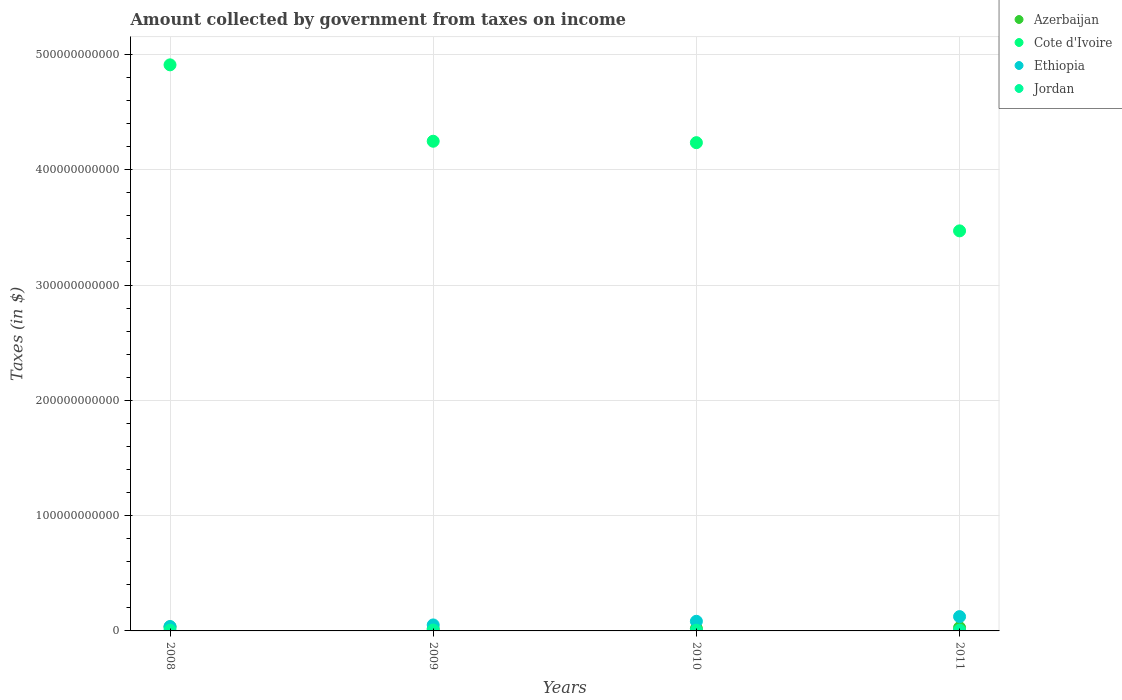Is the number of dotlines equal to the number of legend labels?
Provide a short and direct response. Yes. What is the amount collected by government from taxes on income in Azerbaijan in 2008?
Provide a short and direct response. 3.50e+09. Across all years, what is the maximum amount collected by government from taxes on income in Ethiopia?
Your answer should be very brief. 1.24e+1. Across all years, what is the minimum amount collected by government from taxes on income in Jordan?
Make the answer very short. 6.03e+08. What is the total amount collected by government from taxes on income in Jordan in the graph?
Your response must be concise. 2.66e+09. What is the difference between the amount collected by government from taxes on income in Ethiopia in 2008 and that in 2009?
Offer a terse response. -1.39e+09. What is the difference between the amount collected by government from taxes on income in Ethiopia in 2008 and the amount collected by government from taxes on income in Jordan in 2009?
Your response must be concise. 3.03e+09. What is the average amount collected by government from taxes on income in Ethiopia per year?
Provide a short and direct response. 7.44e+09. In the year 2009, what is the difference between the amount collected by government from taxes on income in Cote d'Ivoire and amount collected by government from taxes on income in Jordan?
Offer a very short reply. 4.24e+11. What is the ratio of the amount collected by government from taxes on income in Ethiopia in 2008 to that in 2011?
Offer a very short reply. 0.31. Is the amount collected by government from taxes on income in Ethiopia in 2008 less than that in 2009?
Provide a short and direct response. Yes. Is the difference between the amount collected by government from taxes on income in Cote d'Ivoire in 2008 and 2009 greater than the difference between the amount collected by government from taxes on income in Jordan in 2008 and 2009?
Keep it short and to the point. Yes. What is the difference between the highest and the second highest amount collected by government from taxes on income in Ethiopia?
Give a very brief answer. 4.06e+09. What is the difference between the highest and the lowest amount collected by government from taxes on income in Ethiopia?
Your response must be concise. 8.62e+09. Is it the case that in every year, the sum of the amount collected by government from taxes on income in Azerbaijan and amount collected by government from taxes on income in Jordan  is greater than the amount collected by government from taxes on income in Cote d'Ivoire?
Your answer should be compact. No. Is the amount collected by government from taxes on income in Ethiopia strictly greater than the amount collected by government from taxes on income in Cote d'Ivoire over the years?
Give a very brief answer. No. Is the amount collected by government from taxes on income in Cote d'Ivoire strictly less than the amount collected by government from taxes on income in Azerbaijan over the years?
Offer a very short reply. No. How many dotlines are there?
Ensure brevity in your answer.  4. How many years are there in the graph?
Your answer should be compact. 4. What is the difference between two consecutive major ticks on the Y-axis?
Offer a very short reply. 1.00e+11. How many legend labels are there?
Offer a terse response. 4. What is the title of the graph?
Your answer should be compact. Amount collected by government from taxes on income. Does "Cyprus" appear as one of the legend labels in the graph?
Offer a very short reply. No. What is the label or title of the Y-axis?
Ensure brevity in your answer.  Taxes (in $). What is the Taxes (in $) in Azerbaijan in 2008?
Keep it short and to the point. 3.50e+09. What is the Taxes (in $) in Cote d'Ivoire in 2008?
Your answer should be compact. 4.91e+11. What is the Taxes (in $) in Ethiopia in 2008?
Make the answer very short. 3.80e+09. What is the Taxes (in $) of Jordan in 2008?
Your answer should be compact. 6.03e+08. What is the Taxes (in $) of Azerbaijan in 2009?
Keep it short and to the point. 1.92e+09. What is the Taxes (in $) in Cote d'Ivoire in 2009?
Keep it short and to the point. 4.25e+11. What is the Taxes (in $) of Ethiopia in 2009?
Ensure brevity in your answer.  5.19e+09. What is the Taxes (in $) in Jordan in 2009?
Make the answer very short. 7.65e+08. What is the Taxes (in $) in Azerbaijan in 2010?
Make the answer very short. 2.03e+09. What is the Taxes (in $) of Cote d'Ivoire in 2010?
Your answer should be compact. 4.24e+11. What is the Taxes (in $) in Ethiopia in 2010?
Offer a very short reply. 8.35e+09. What is the Taxes (in $) in Jordan in 2010?
Your response must be concise. 6.25e+08. What is the Taxes (in $) of Azerbaijan in 2011?
Give a very brief answer. 2.86e+09. What is the Taxes (in $) of Cote d'Ivoire in 2011?
Keep it short and to the point. 3.47e+11. What is the Taxes (in $) of Ethiopia in 2011?
Keep it short and to the point. 1.24e+1. What is the Taxes (in $) in Jordan in 2011?
Keep it short and to the point. 6.68e+08. Across all years, what is the maximum Taxes (in $) in Azerbaijan?
Your response must be concise. 3.50e+09. Across all years, what is the maximum Taxes (in $) in Cote d'Ivoire?
Your answer should be compact. 4.91e+11. Across all years, what is the maximum Taxes (in $) of Ethiopia?
Provide a short and direct response. 1.24e+1. Across all years, what is the maximum Taxes (in $) in Jordan?
Your response must be concise. 7.65e+08. Across all years, what is the minimum Taxes (in $) in Azerbaijan?
Offer a very short reply. 1.92e+09. Across all years, what is the minimum Taxes (in $) in Cote d'Ivoire?
Your answer should be very brief. 3.47e+11. Across all years, what is the minimum Taxes (in $) in Ethiopia?
Your answer should be very brief. 3.80e+09. Across all years, what is the minimum Taxes (in $) of Jordan?
Keep it short and to the point. 6.03e+08. What is the total Taxes (in $) in Azerbaijan in the graph?
Provide a short and direct response. 1.03e+1. What is the total Taxes (in $) in Cote d'Ivoire in the graph?
Your answer should be compact. 1.69e+12. What is the total Taxes (in $) of Ethiopia in the graph?
Ensure brevity in your answer.  2.98e+1. What is the total Taxes (in $) of Jordan in the graph?
Your response must be concise. 2.66e+09. What is the difference between the Taxes (in $) of Azerbaijan in 2008 and that in 2009?
Provide a succinct answer. 1.58e+09. What is the difference between the Taxes (in $) of Cote d'Ivoire in 2008 and that in 2009?
Ensure brevity in your answer.  6.63e+1. What is the difference between the Taxes (in $) of Ethiopia in 2008 and that in 2009?
Your answer should be very brief. -1.39e+09. What is the difference between the Taxes (in $) of Jordan in 2008 and that in 2009?
Ensure brevity in your answer.  -1.61e+08. What is the difference between the Taxes (in $) in Azerbaijan in 2008 and that in 2010?
Make the answer very short. 1.47e+09. What is the difference between the Taxes (in $) in Cote d'Ivoire in 2008 and that in 2010?
Make the answer very short. 6.75e+1. What is the difference between the Taxes (in $) in Ethiopia in 2008 and that in 2010?
Keep it short and to the point. -4.56e+09. What is the difference between the Taxes (in $) of Jordan in 2008 and that in 2010?
Provide a short and direct response. -2.12e+07. What is the difference between the Taxes (in $) of Azerbaijan in 2008 and that in 2011?
Provide a short and direct response. 6.37e+08. What is the difference between the Taxes (in $) in Cote d'Ivoire in 2008 and that in 2011?
Your answer should be compact. 1.44e+11. What is the difference between the Taxes (in $) of Ethiopia in 2008 and that in 2011?
Your response must be concise. -8.62e+09. What is the difference between the Taxes (in $) of Jordan in 2008 and that in 2011?
Make the answer very short. -6.41e+07. What is the difference between the Taxes (in $) of Azerbaijan in 2009 and that in 2010?
Make the answer very short. -1.06e+08. What is the difference between the Taxes (in $) of Cote d'Ivoire in 2009 and that in 2010?
Your answer should be very brief. 1.24e+09. What is the difference between the Taxes (in $) in Ethiopia in 2009 and that in 2010?
Make the answer very short. -3.16e+09. What is the difference between the Taxes (in $) in Jordan in 2009 and that in 2010?
Provide a short and direct response. 1.40e+08. What is the difference between the Taxes (in $) in Azerbaijan in 2009 and that in 2011?
Offer a terse response. -9.41e+08. What is the difference between the Taxes (in $) of Cote d'Ivoire in 2009 and that in 2011?
Give a very brief answer. 7.77e+1. What is the difference between the Taxes (in $) of Ethiopia in 2009 and that in 2011?
Provide a short and direct response. -7.22e+09. What is the difference between the Taxes (in $) of Jordan in 2009 and that in 2011?
Your answer should be very brief. 9.72e+07. What is the difference between the Taxes (in $) of Azerbaijan in 2010 and that in 2011?
Provide a succinct answer. -8.35e+08. What is the difference between the Taxes (in $) in Cote d'Ivoire in 2010 and that in 2011?
Ensure brevity in your answer.  7.65e+1. What is the difference between the Taxes (in $) of Ethiopia in 2010 and that in 2011?
Your answer should be compact. -4.06e+09. What is the difference between the Taxes (in $) in Jordan in 2010 and that in 2011?
Make the answer very short. -4.29e+07. What is the difference between the Taxes (in $) of Azerbaijan in 2008 and the Taxes (in $) of Cote d'Ivoire in 2009?
Make the answer very short. -4.21e+11. What is the difference between the Taxes (in $) of Azerbaijan in 2008 and the Taxes (in $) of Ethiopia in 2009?
Provide a short and direct response. -1.70e+09. What is the difference between the Taxes (in $) of Azerbaijan in 2008 and the Taxes (in $) of Jordan in 2009?
Provide a short and direct response. 2.73e+09. What is the difference between the Taxes (in $) in Cote d'Ivoire in 2008 and the Taxes (in $) in Ethiopia in 2009?
Make the answer very short. 4.86e+11. What is the difference between the Taxes (in $) of Cote d'Ivoire in 2008 and the Taxes (in $) of Jordan in 2009?
Your response must be concise. 4.90e+11. What is the difference between the Taxes (in $) in Ethiopia in 2008 and the Taxes (in $) in Jordan in 2009?
Keep it short and to the point. 3.03e+09. What is the difference between the Taxes (in $) in Azerbaijan in 2008 and the Taxes (in $) in Cote d'Ivoire in 2010?
Make the answer very short. -4.20e+11. What is the difference between the Taxes (in $) in Azerbaijan in 2008 and the Taxes (in $) in Ethiopia in 2010?
Offer a terse response. -4.86e+09. What is the difference between the Taxes (in $) in Azerbaijan in 2008 and the Taxes (in $) in Jordan in 2010?
Your answer should be compact. 2.87e+09. What is the difference between the Taxes (in $) in Cote d'Ivoire in 2008 and the Taxes (in $) in Ethiopia in 2010?
Keep it short and to the point. 4.83e+11. What is the difference between the Taxes (in $) of Cote d'Ivoire in 2008 and the Taxes (in $) of Jordan in 2010?
Offer a terse response. 4.90e+11. What is the difference between the Taxes (in $) of Ethiopia in 2008 and the Taxes (in $) of Jordan in 2010?
Make the answer very short. 3.17e+09. What is the difference between the Taxes (in $) in Azerbaijan in 2008 and the Taxes (in $) in Cote d'Ivoire in 2011?
Keep it short and to the point. -3.44e+11. What is the difference between the Taxes (in $) in Azerbaijan in 2008 and the Taxes (in $) in Ethiopia in 2011?
Provide a succinct answer. -8.92e+09. What is the difference between the Taxes (in $) in Azerbaijan in 2008 and the Taxes (in $) in Jordan in 2011?
Keep it short and to the point. 2.83e+09. What is the difference between the Taxes (in $) in Cote d'Ivoire in 2008 and the Taxes (in $) in Ethiopia in 2011?
Offer a terse response. 4.79e+11. What is the difference between the Taxes (in $) of Cote d'Ivoire in 2008 and the Taxes (in $) of Jordan in 2011?
Offer a terse response. 4.90e+11. What is the difference between the Taxes (in $) in Ethiopia in 2008 and the Taxes (in $) in Jordan in 2011?
Your answer should be compact. 3.13e+09. What is the difference between the Taxes (in $) in Azerbaijan in 2009 and the Taxes (in $) in Cote d'Ivoire in 2010?
Give a very brief answer. -4.22e+11. What is the difference between the Taxes (in $) in Azerbaijan in 2009 and the Taxes (in $) in Ethiopia in 2010?
Offer a terse response. -6.43e+09. What is the difference between the Taxes (in $) of Azerbaijan in 2009 and the Taxes (in $) of Jordan in 2010?
Offer a very short reply. 1.30e+09. What is the difference between the Taxes (in $) in Cote d'Ivoire in 2009 and the Taxes (in $) in Ethiopia in 2010?
Your response must be concise. 4.16e+11. What is the difference between the Taxes (in $) in Cote d'Ivoire in 2009 and the Taxes (in $) in Jordan in 2010?
Keep it short and to the point. 4.24e+11. What is the difference between the Taxes (in $) in Ethiopia in 2009 and the Taxes (in $) in Jordan in 2010?
Your answer should be compact. 4.57e+09. What is the difference between the Taxes (in $) of Azerbaijan in 2009 and the Taxes (in $) of Cote d'Ivoire in 2011?
Your response must be concise. -3.45e+11. What is the difference between the Taxes (in $) in Azerbaijan in 2009 and the Taxes (in $) in Ethiopia in 2011?
Offer a very short reply. -1.05e+1. What is the difference between the Taxes (in $) in Azerbaijan in 2009 and the Taxes (in $) in Jordan in 2011?
Give a very brief answer. 1.25e+09. What is the difference between the Taxes (in $) in Cote d'Ivoire in 2009 and the Taxes (in $) in Ethiopia in 2011?
Give a very brief answer. 4.12e+11. What is the difference between the Taxes (in $) of Cote d'Ivoire in 2009 and the Taxes (in $) of Jordan in 2011?
Give a very brief answer. 4.24e+11. What is the difference between the Taxes (in $) of Ethiopia in 2009 and the Taxes (in $) of Jordan in 2011?
Provide a succinct answer. 4.53e+09. What is the difference between the Taxes (in $) of Azerbaijan in 2010 and the Taxes (in $) of Cote d'Ivoire in 2011?
Your answer should be very brief. -3.45e+11. What is the difference between the Taxes (in $) in Azerbaijan in 2010 and the Taxes (in $) in Ethiopia in 2011?
Keep it short and to the point. -1.04e+1. What is the difference between the Taxes (in $) in Azerbaijan in 2010 and the Taxes (in $) in Jordan in 2011?
Offer a very short reply. 1.36e+09. What is the difference between the Taxes (in $) of Cote d'Ivoire in 2010 and the Taxes (in $) of Ethiopia in 2011?
Your answer should be compact. 4.11e+11. What is the difference between the Taxes (in $) of Cote d'Ivoire in 2010 and the Taxes (in $) of Jordan in 2011?
Offer a terse response. 4.23e+11. What is the difference between the Taxes (in $) of Ethiopia in 2010 and the Taxes (in $) of Jordan in 2011?
Offer a very short reply. 7.69e+09. What is the average Taxes (in $) of Azerbaijan per year?
Your answer should be compact. 2.58e+09. What is the average Taxes (in $) of Cote d'Ivoire per year?
Provide a succinct answer. 4.22e+11. What is the average Taxes (in $) of Ethiopia per year?
Your response must be concise. 7.44e+09. What is the average Taxes (in $) in Jordan per year?
Ensure brevity in your answer.  6.65e+08. In the year 2008, what is the difference between the Taxes (in $) in Azerbaijan and Taxes (in $) in Cote d'Ivoire?
Offer a terse response. -4.88e+11. In the year 2008, what is the difference between the Taxes (in $) of Azerbaijan and Taxes (in $) of Ethiopia?
Make the answer very short. -3.00e+08. In the year 2008, what is the difference between the Taxes (in $) in Azerbaijan and Taxes (in $) in Jordan?
Keep it short and to the point. 2.90e+09. In the year 2008, what is the difference between the Taxes (in $) in Cote d'Ivoire and Taxes (in $) in Ethiopia?
Provide a short and direct response. 4.87e+11. In the year 2008, what is the difference between the Taxes (in $) of Cote d'Ivoire and Taxes (in $) of Jordan?
Provide a succinct answer. 4.90e+11. In the year 2008, what is the difference between the Taxes (in $) of Ethiopia and Taxes (in $) of Jordan?
Offer a terse response. 3.20e+09. In the year 2009, what is the difference between the Taxes (in $) of Azerbaijan and Taxes (in $) of Cote d'Ivoire?
Provide a short and direct response. -4.23e+11. In the year 2009, what is the difference between the Taxes (in $) in Azerbaijan and Taxes (in $) in Ethiopia?
Your response must be concise. -3.27e+09. In the year 2009, what is the difference between the Taxes (in $) in Azerbaijan and Taxes (in $) in Jordan?
Keep it short and to the point. 1.16e+09. In the year 2009, what is the difference between the Taxes (in $) in Cote d'Ivoire and Taxes (in $) in Ethiopia?
Ensure brevity in your answer.  4.20e+11. In the year 2009, what is the difference between the Taxes (in $) in Cote d'Ivoire and Taxes (in $) in Jordan?
Give a very brief answer. 4.24e+11. In the year 2009, what is the difference between the Taxes (in $) of Ethiopia and Taxes (in $) of Jordan?
Your answer should be compact. 4.43e+09. In the year 2010, what is the difference between the Taxes (in $) of Azerbaijan and Taxes (in $) of Cote d'Ivoire?
Your answer should be very brief. -4.21e+11. In the year 2010, what is the difference between the Taxes (in $) of Azerbaijan and Taxes (in $) of Ethiopia?
Your answer should be compact. -6.33e+09. In the year 2010, what is the difference between the Taxes (in $) of Azerbaijan and Taxes (in $) of Jordan?
Give a very brief answer. 1.40e+09. In the year 2010, what is the difference between the Taxes (in $) in Cote d'Ivoire and Taxes (in $) in Ethiopia?
Your answer should be compact. 4.15e+11. In the year 2010, what is the difference between the Taxes (in $) in Cote d'Ivoire and Taxes (in $) in Jordan?
Provide a succinct answer. 4.23e+11. In the year 2010, what is the difference between the Taxes (in $) in Ethiopia and Taxes (in $) in Jordan?
Give a very brief answer. 7.73e+09. In the year 2011, what is the difference between the Taxes (in $) of Azerbaijan and Taxes (in $) of Cote d'Ivoire?
Ensure brevity in your answer.  -3.44e+11. In the year 2011, what is the difference between the Taxes (in $) in Azerbaijan and Taxes (in $) in Ethiopia?
Provide a succinct answer. -9.55e+09. In the year 2011, what is the difference between the Taxes (in $) of Azerbaijan and Taxes (in $) of Jordan?
Provide a succinct answer. 2.19e+09. In the year 2011, what is the difference between the Taxes (in $) in Cote d'Ivoire and Taxes (in $) in Ethiopia?
Provide a short and direct response. 3.35e+11. In the year 2011, what is the difference between the Taxes (in $) in Cote d'Ivoire and Taxes (in $) in Jordan?
Give a very brief answer. 3.46e+11. In the year 2011, what is the difference between the Taxes (in $) in Ethiopia and Taxes (in $) in Jordan?
Your answer should be very brief. 1.17e+1. What is the ratio of the Taxes (in $) of Azerbaijan in 2008 to that in 2009?
Your answer should be compact. 1.82. What is the ratio of the Taxes (in $) of Cote d'Ivoire in 2008 to that in 2009?
Give a very brief answer. 1.16. What is the ratio of the Taxes (in $) in Ethiopia in 2008 to that in 2009?
Ensure brevity in your answer.  0.73. What is the ratio of the Taxes (in $) of Jordan in 2008 to that in 2009?
Make the answer very short. 0.79. What is the ratio of the Taxes (in $) in Azerbaijan in 2008 to that in 2010?
Provide a short and direct response. 1.73. What is the ratio of the Taxes (in $) in Cote d'Ivoire in 2008 to that in 2010?
Offer a terse response. 1.16. What is the ratio of the Taxes (in $) in Ethiopia in 2008 to that in 2010?
Make the answer very short. 0.45. What is the ratio of the Taxes (in $) in Jordan in 2008 to that in 2010?
Offer a very short reply. 0.97. What is the ratio of the Taxes (in $) of Azerbaijan in 2008 to that in 2011?
Give a very brief answer. 1.22. What is the ratio of the Taxes (in $) in Cote d'Ivoire in 2008 to that in 2011?
Your answer should be compact. 1.42. What is the ratio of the Taxes (in $) in Ethiopia in 2008 to that in 2011?
Offer a very short reply. 0.31. What is the ratio of the Taxes (in $) of Jordan in 2008 to that in 2011?
Ensure brevity in your answer.  0.9. What is the ratio of the Taxes (in $) in Azerbaijan in 2009 to that in 2010?
Give a very brief answer. 0.95. What is the ratio of the Taxes (in $) of Cote d'Ivoire in 2009 to that in 2010?
Offer a terse response. 1. What is the ratio of the Taxes (in $) of Ethiopia in 2009 to that in 2010?
Provide a succinct answer. 0.62. What is the ratio of the Taxes (in $) of Jordan in 2009 to that in 2010?
Provide a short and direct response. 1.22. What is the ratio of the Taxes (in $) in Azerbaijan in 2009 to that in 2011?
Provide a short and direct response. 0.67. What is the ratio of the Taxes (in $) in Cote d'Ivoire in 2009 to that in 2011?
Your answer should be very brief. 1.22. What is the ratio of the Taxes (in $) of Ethiopia in 2009 to that in 2011?
Ensure brevity in your answer.  0.42. What is the ratio of the Taxes (in $) in Jordan in 2009 to that in 2011?
Provide a short and direct response. 1.15. What is the ratio of the Taxes (in $) in Azerbaijan in 2010 to that in 2011?
Your answer should be compact. 0.71. What is the ratio of the Taxes (in $) of Cote d'Ivoire in 2010 to that in 2011?
Keep it short and to the point. 1.22. What is the ratio of the Taxes (in $) in Ethiopia in 2010 to that in 2011?
Your response must be concise. 0.67. What is the ratio of the Taxes (in $) in Jordan in 2010 to that in 2011?
Offer a terse response. 0.94. What is the difference between the highest and the second highest Taxes (in $) in Azerbaijan?
Ensure brevity in your answer.  6.37e+08. What is the difference between the highest and the second highest Taxes (in $) in Cote d'Ivoire?
Make the answer very short. 6.63e+1. What is the difference between the highest and the second highest Taxes (in $) of Ethiopia?
Your answer should be very brief. 4.06e+09. What is the difference between the highest and the second highest Taxes (in $) in Jordan?
Your response must be concise. 9.72e+07. What is the difference between the highest and the lowest Taxes (in $) in Azerbaijan?
Make the answer very short. 1.58e+09. What is the difference between the highest and the lowest Taxes (in $) of Cote d'Ivoire?
Your response must be concise. 1.44e+11. What is the difference between the highest and the lowest Taxes (in $) of Ethiopia?
Offer a very short reply. 8.62e+09. What is the difference between the highest and the lowest Taxes (in $) of Jordan?
Your response must be concise. 1.61e+08. 